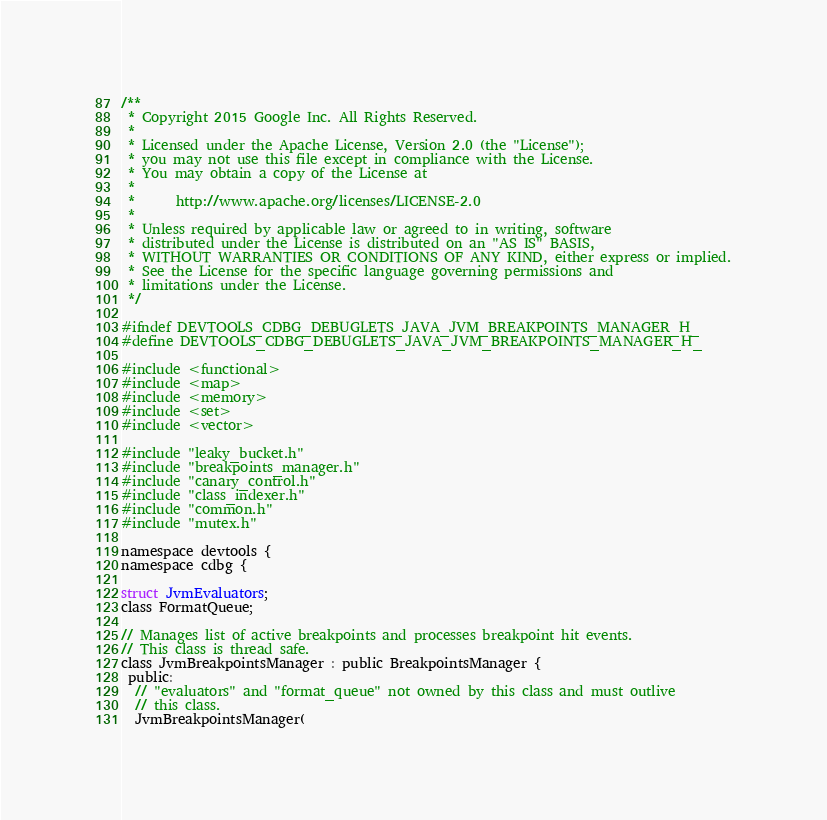Convert code to text. <code><loc_0><loc_0><loc_500><loc_500><_C_>/**
 * Copyright 2015 Google Inc. All Rights Reserved.
 *
 * Licensed under the Apache License, Version 2.0 (the "License");
 * you may not use this file except in compliance with the License.
 * You may obtain a copy of the License at
 *
 *      http://www.apache.org/licenses/LICENSE-2.0
 *
 * Unless required by applicable law or agreed to in writing, software
 * distributed under the License is distributed on an "AS IS" BASIS,
 * WITHOUT WARRANTIES OR CONDITIONS OF ANY KIND, either express or implied.
 * See the License for the specific language governing permissions and
 * limitations under the License.
 */

#ifndef DEVTOOLS_CDBG_DEBUGLETS_JAVA_JVM_BREAKPOINTS_MANAGER_H_
#define DEVTOOLS_CDBG_DEBUGLETS_JAVA_JVM_BREAKPOINTS_MANAGER_H_

#include <functional>
#include <map>
#include <memory>
#include <set>
#include <vector>

#include "leaky_bucket.h"
#include "breakpoints_manager.h"
#include "canary_control.h"
#include "class_indexer.h"
#include "common.h"
#include "mutex.h"

namespace devtools {
namespace cdbg {

struct JvmEvaluators;
class FormatQueue;

// Manages list of active breakpoints and processes breakpoint hit events.
// This class is thread safe.
class JvmBreakpointsManager : public BreakpointsManager {
 public:
  // "evaluators" and "format_queue" not owned by this class and must outlive
  // this class.
  JvmBreakpointsManager(</code> 